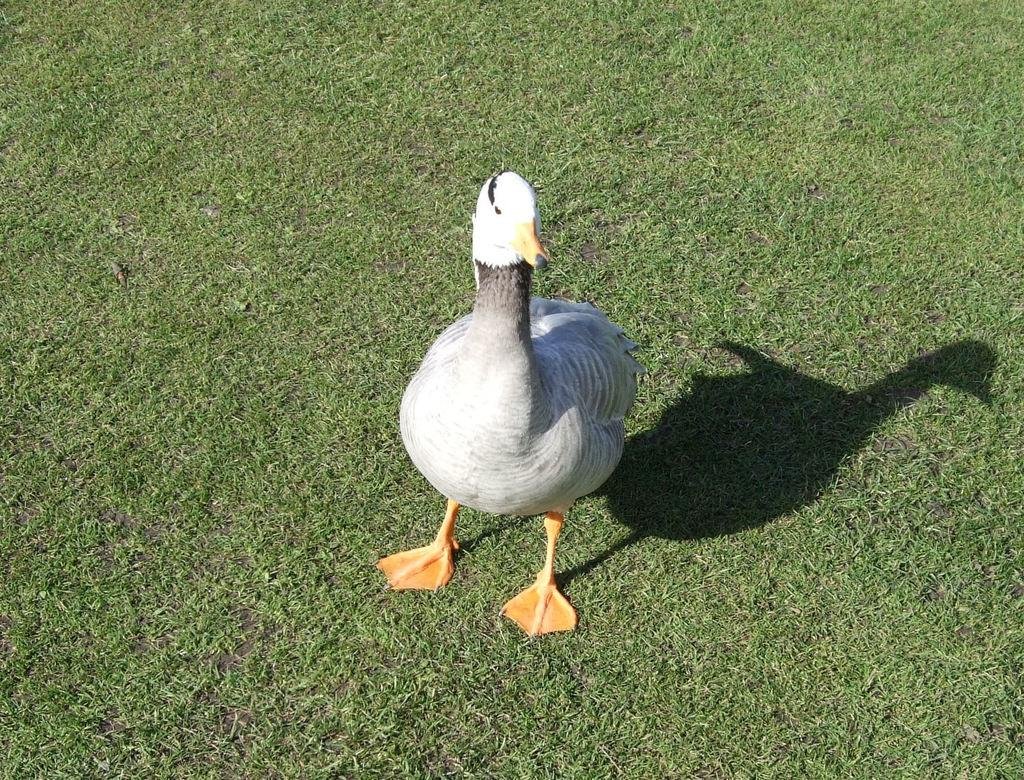What type of animal is in the image? There is a white duck in the image. What is the duck standing on? The duck is standing on the grass ground. What type of toothbrush is the duck using in the image? There is no toothbrush present in the image, and the duck is not using any such object. 